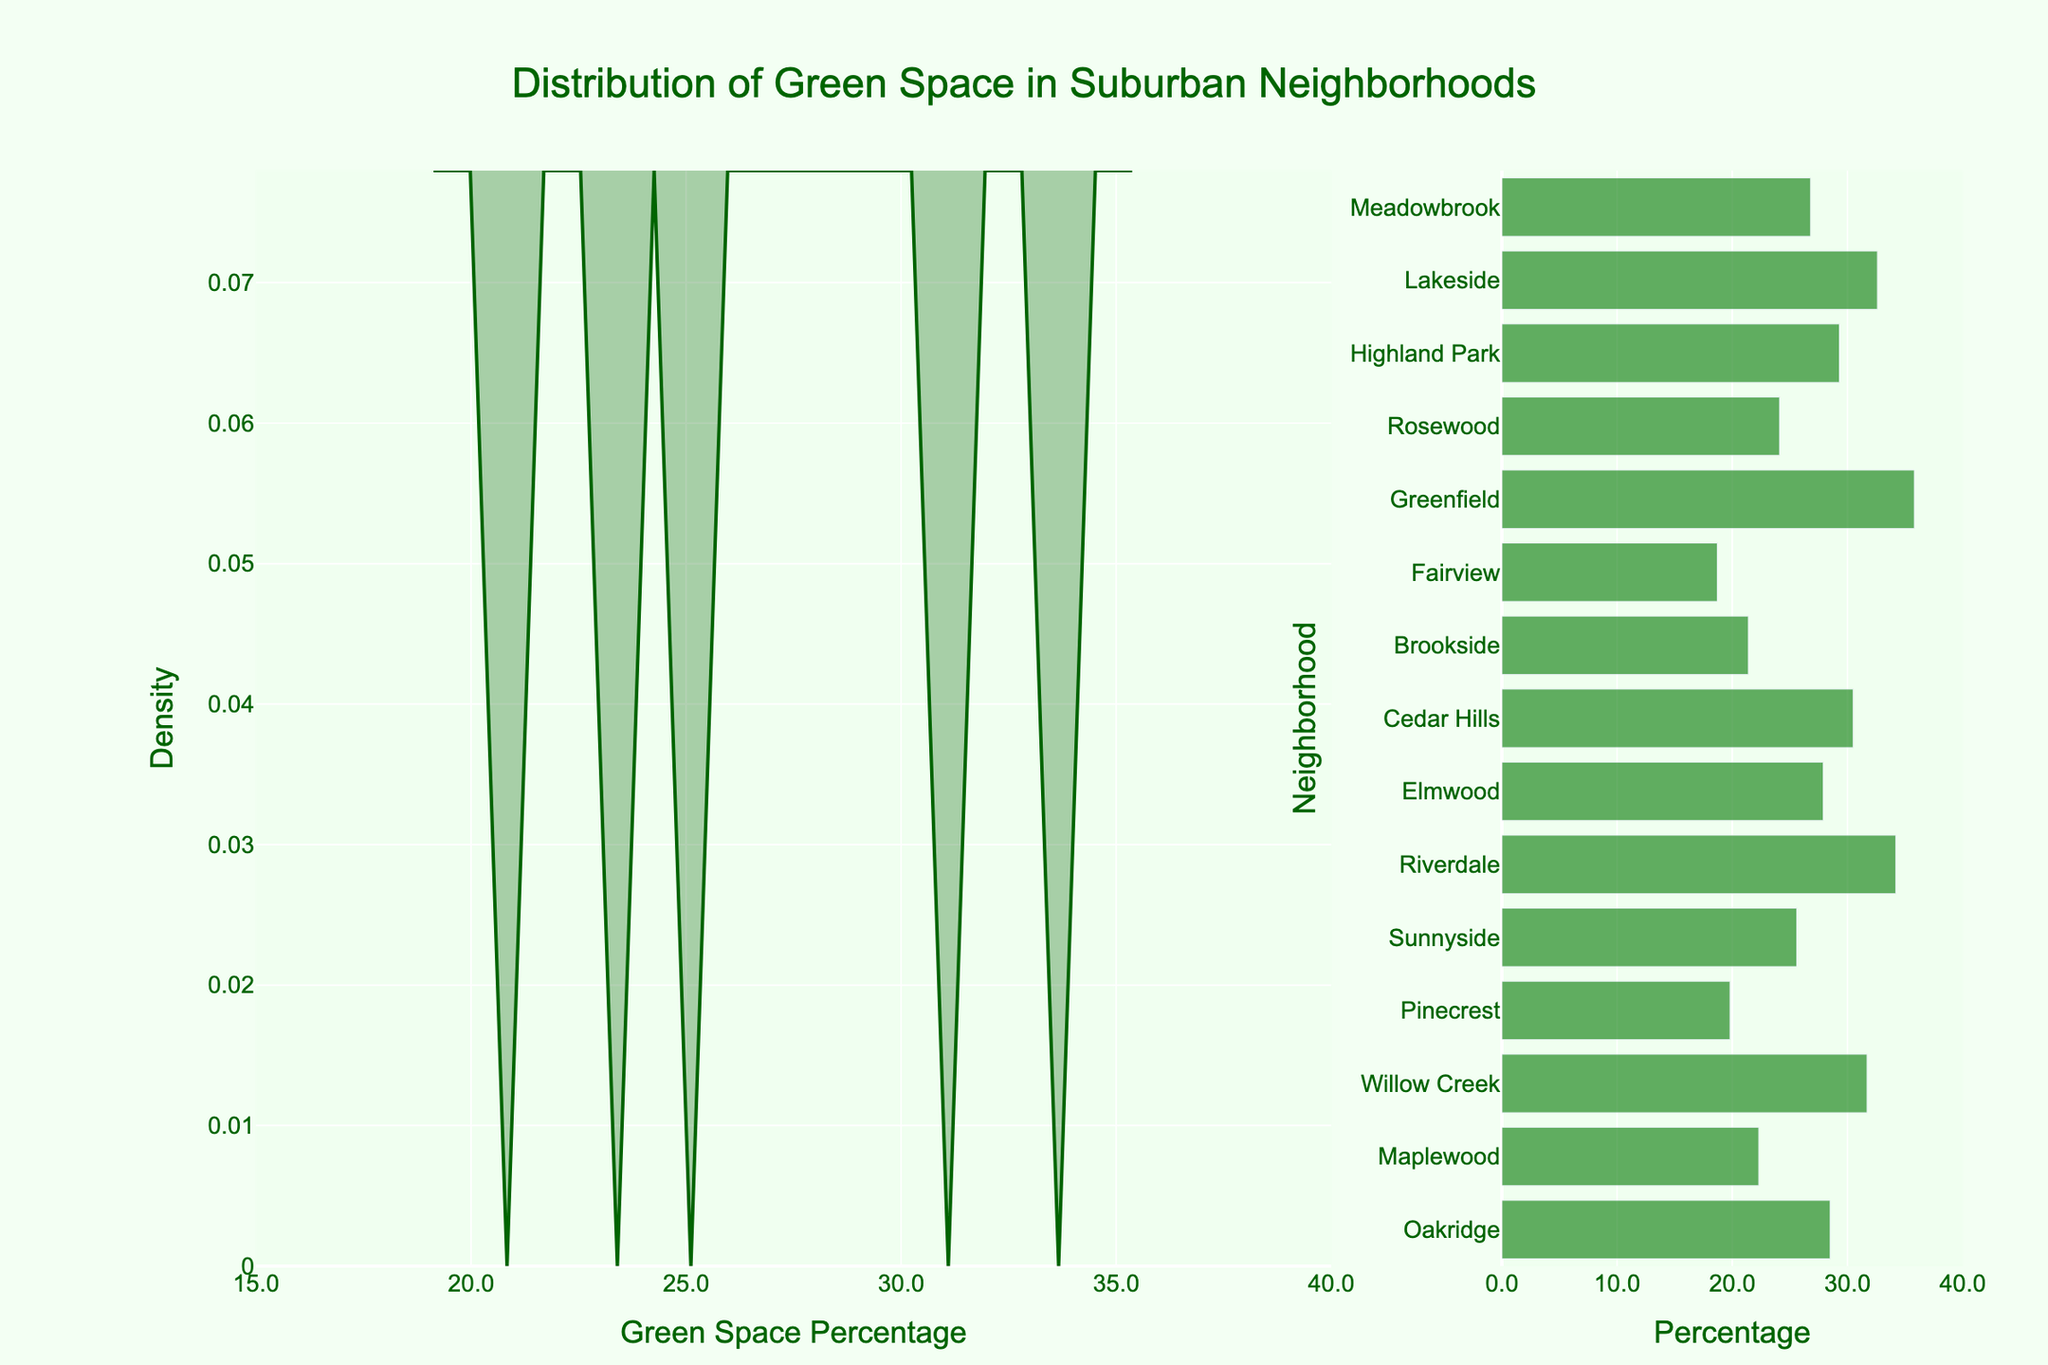What's the title of the figure? The title is present at the top of the figure.
Answer: Distribution of Green Space in Suburban Neighborhoods What neighborhood has the highest green space percentage? By examining the bar graph, you can see the green space percentage for each neighborhood.
Answer: Greenfield What is the range of green space percentages shown in the figure? To determine the range, identify the minimum and maximum values on the x-axis of the density plot.
Answer: 18.7 to 35.8 How many neighborhoods have less than 25% green space? Count the bars in the bar graph that fall below 25% on the x-axis.
Answer: 5 Which neighborhood has the lowest green space percentage? By observing the bar graph, you can find the neighborhood with the smallest value on the x-axis.
Answer: Fairview What is the most common range of green space percentages in the neighborhoods? Look at the horizontal density plot to see where the density is highest, indicating the most common values.
Answer: Around 30-35% How many neighborhoods have more than 30% green space? Count the bars in the bar graph that represent green space percentages higher than 30%.
Answer: 5 Compare Elmwood and Highland Park, which has a higher green space percentage? Locate both neighborhoods on the bar graph and compare their values.
Answer: Highland Park What does the x-axis represent in the density plot? The label at the bottom of the x-axis in the density plot will provide this information.
Answer: Green Space Percentage Is the distribution of green space percentages skewed towards higher or lower values? Examine the shape of the density plot; if the plot is taller on the left, it's skewed towards lower values, and if it's taller on the right, it's skewed towards higher values.
Answer: Higher values 